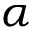Convert formula to latex. <formula><loc_0><loc_0><loc_500><loc_500>\alpha</formula> 